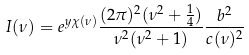<formula> <loc_0><loc_0><loc_500><loc_500>I ( \nu ) = e ^ { y \chi ( \nu ) } \frac { ( 2 \pi ) ^ { 2 } ( \nu ^ { 2 } + \frac { 1 } { 4 } ) } { \nu ^ { 2 } ( \nu ^ { 2 } + 1 ) } \frac { b ^ { 2 } } { c ( \nu ) ^ { 2 } }</formula> 